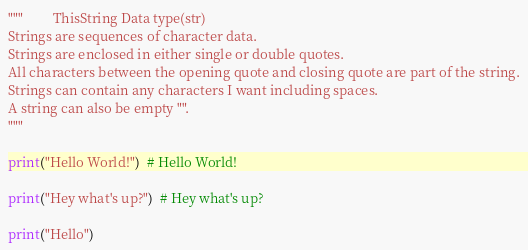<code> <loc_0><loc_0><loc_500><loc_500><_Python_>"""         ThisString Data type(str)
Strings are sequences of character data.
Strings are enclosed in either single or double quotes.
All characters between the opening quote and closing quote are part of the string.
Strings can contain any characters I want including spaces.
A string can also be empty "".
"""

print("Hello World!")  # Hello World!

print("Hey what's up?")  # Hey what's up?

print("Hello")</code> 